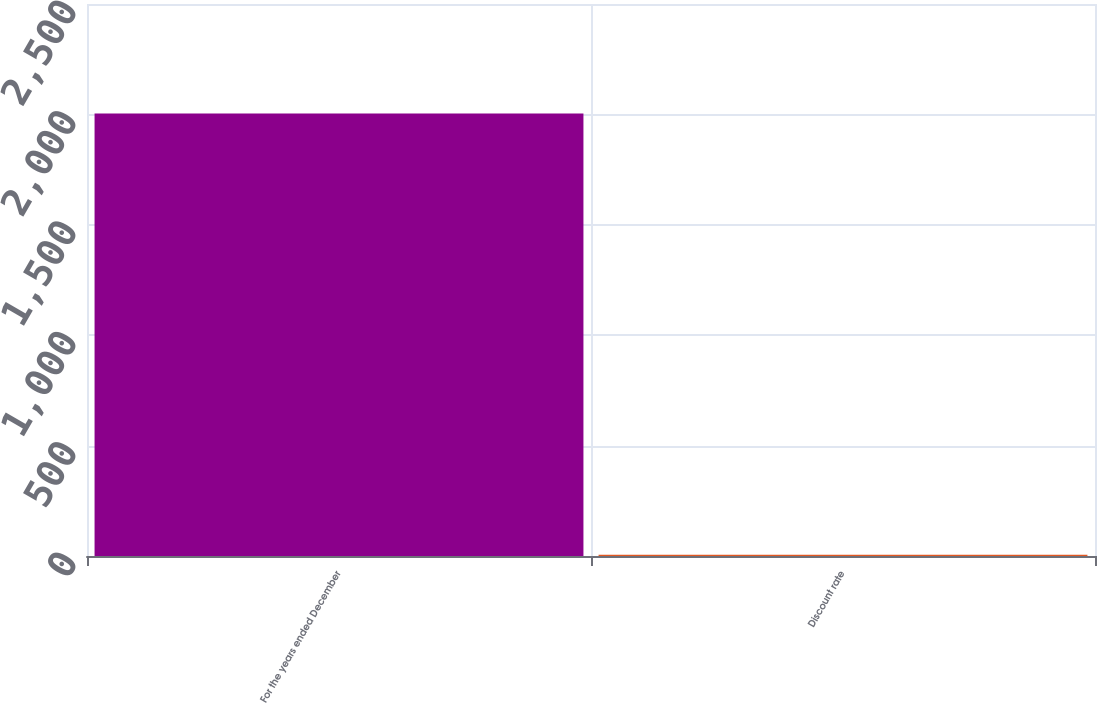Convert chart to OTSL. <chart><loc_0><loc_0><loc_500><loc_500><bar_chart><fcel>For the years ended December<fcel>Discount rate<nl><fcel>2004<fcel>6<nl></chart> 